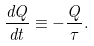<formula> <loc_0><loc_0><loc_500><loc_500>\frac { d Q } { d t } \equiv - \frac { Q } { \tau } .</formula> 